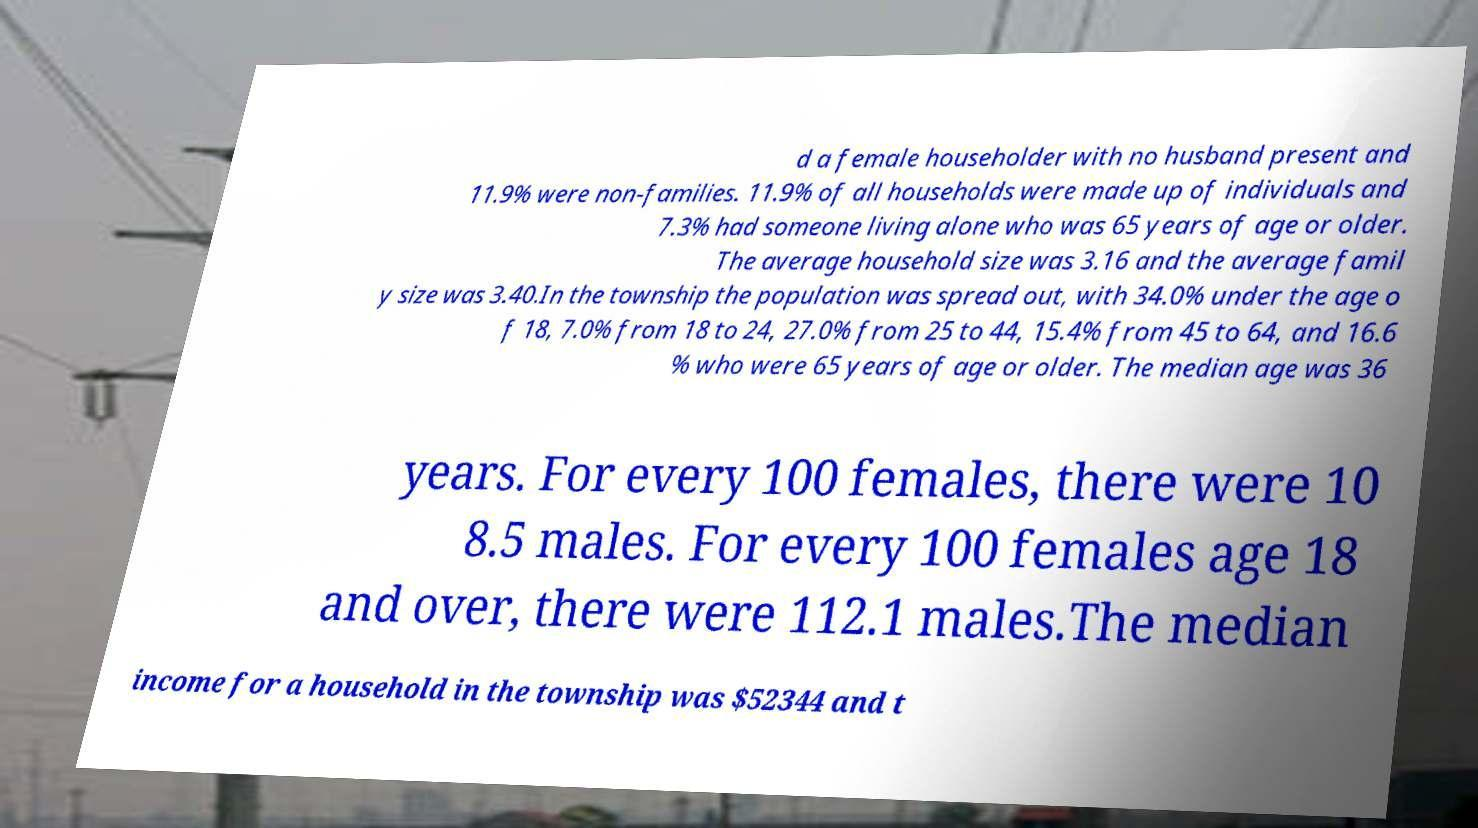Can you read and provide the text displayed in the image?This photo seems to have some interesting text. Can you extract and type it out for me? d a female householder with no husband present and 11.9% were non-families. 11.9% of all households were made up of individuals and 7.3% had someone living alone who was 65 years of age or older. The average household size was 3.16 and the average famil y size was 3.40.In the township the population was spread out, with 34.0% under the age o f 18, 7.0% from 18 to 24, 27.0% from 25 to 44, 15.4% from 45 to 64, and 16.6 % who were 65 years of age or older. The median age was 36 years. For every 100 females, there were 10 8.5 males. For every 100 females age 18 and over, there were 112.1 males.The median income for a household in the township was $52344 and t 